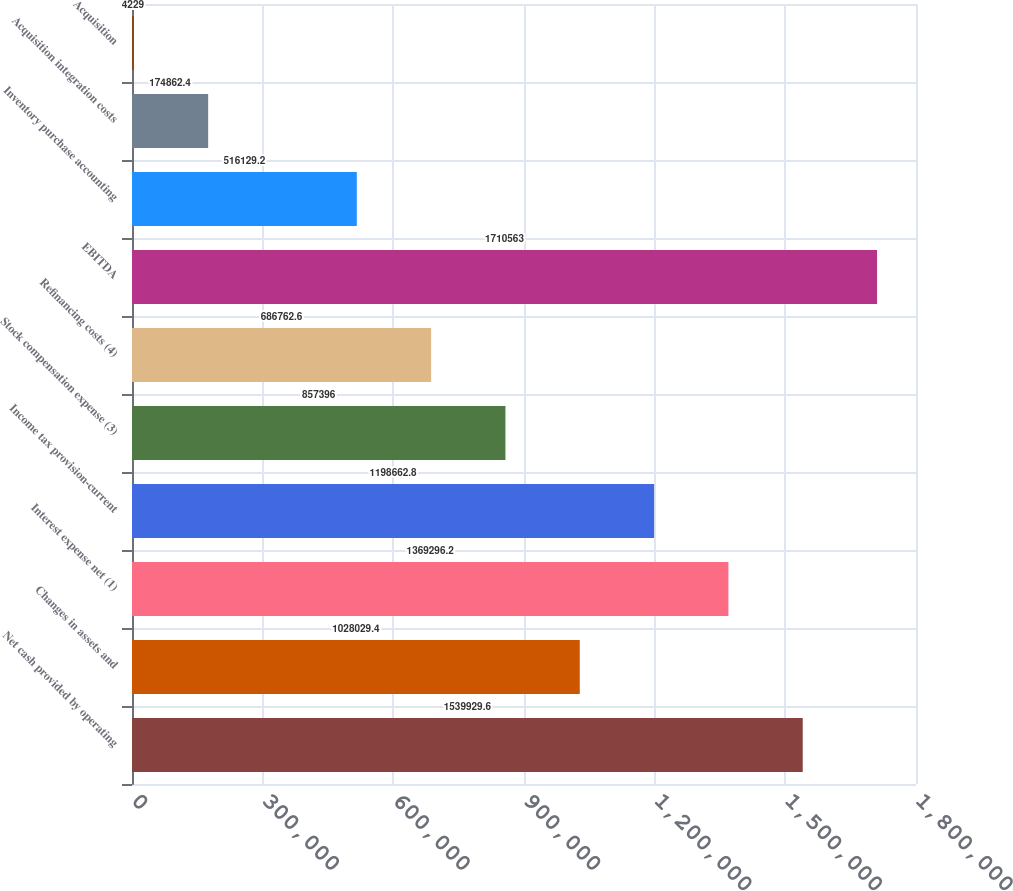Convert chart to OTSL. <chart><loc_0><loc_0><loc_500><loc_500><bar_chart><fcel>Net cash provided by operating<fcel>Changes in assets and<fcel>Interest expense net (1)<fcel>Income tax provision-current<fcel>Stock compensation expense (3)<fcel>Refinancing costs (4)<fcel>EBITDA<fcel>Inventory purchase accounting<fcel>Acquisition integration costs<fcel>Acquisition<nl><fcel>1.53993e+06<fcel>1.02803e+06<fcel>1.3693e+06<fcel>1.19866e+06<fcel>857396<fcel>686763<fcel>1.71056e+06<fcel>516129<fcel>174862<fcel>4229<nl></chart> 